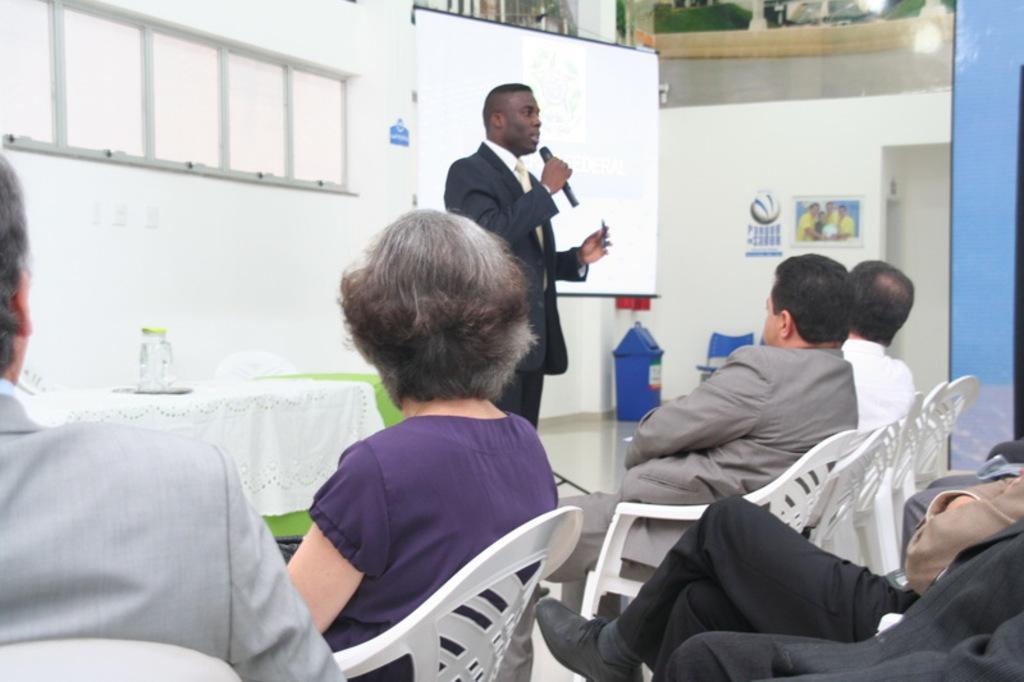Describe this image in one or two sentences. There is a man in this picture holding a mic and speaking, standing in front of the people who are sitting in the chairs. In the background there is a projector display screen and a table on which a glass jar was placed. We can observe a wall and windows here. 